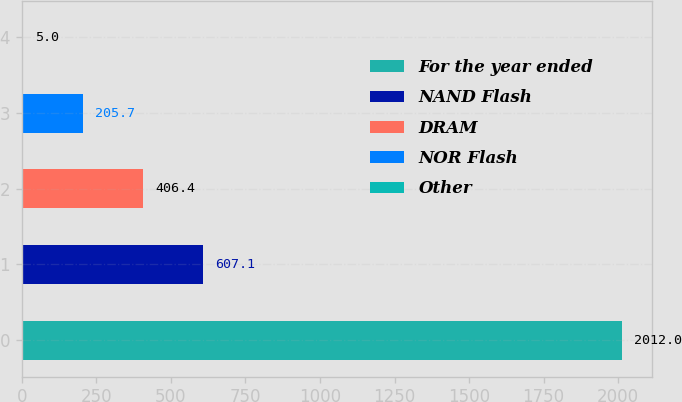<chart> <loc_0><loc_0><loc_500><loc_500><bar_chart><fcel>For the year ended<fcel>NAND Flash<fcel>DRAM<fcel>NOR Flash<fcel>Other<nl><fcel>2012<fcel>607.1<fcel>406.4<fcel>205.7<fcel>5<nl></chart> 